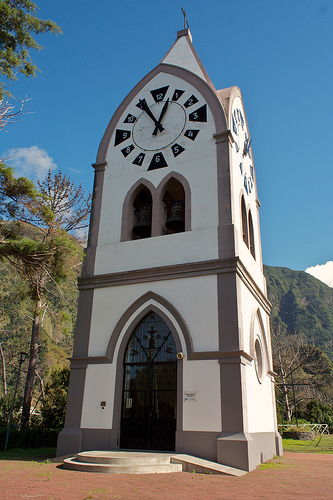Are there any clocks or fire hydrants? Yes, there is a clock visible in the image. 